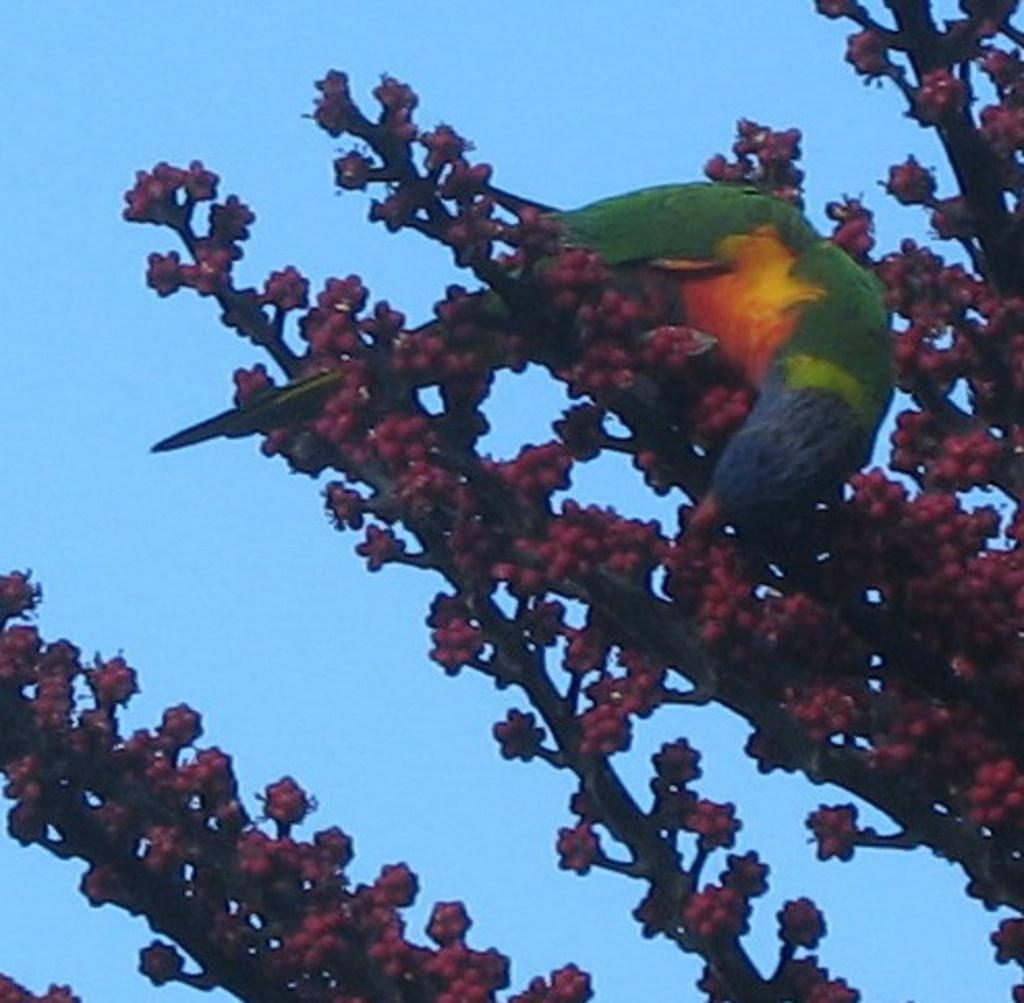What type of animal can be seen in the image? There is a bird in the image. Where is the bird located in the image? The bird is standing on a branch. What is present on the branches in the image? There are red fruits on the branches. What can be seen in the background of the image? The sky is visible behind the bird. What type of feeling does the bird have in the morning when it sees its family in the image? There is no information about the bird's feelings, the time of day, or the presence of a family in the image. 